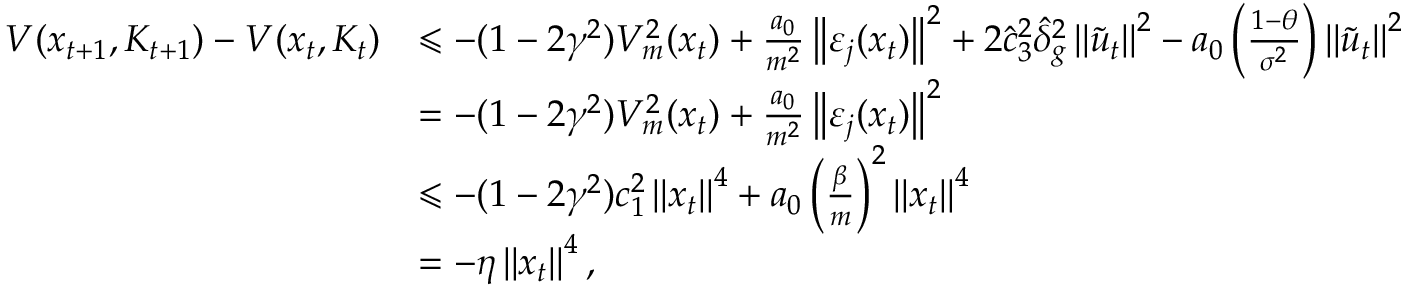Convert formula to latex. <formula><loc_0><loc_0><loc_500><loc_500>\begin{array} { r l } { V ( x _ { t + 1 } , K _ { t + 1 } ) - V ( x _ { t } , K _ { t } ) } & { \leqslant - ( 1 - 2 \gamma ^ { 2 } ) V _ { m } ^ { 2 } ( x _ { t } ) + \frac { a _ { 0 } } { m ^ { 2 } } \left \| \varepsilon _ { j } ( x _ { t } ) \right \| ^ { 2 } + 2 \hat { c } _ { 3 } ^ { 2 } \hat { \delta } _ { g } ^ { 2 } \left \| \tilde { u } _ { t } \right \| ^ { 2 } - a _ { 0 } \left ( \frac { 1 - \theta } { \sigma ^ { 2 } } \right ) \left \| \tilde { u } _ { t } \right \| ^ { 2 } } \\ & { = - ( 1 - 2 \gamma ^ { 2 } ) V _ { m } ^ { 2 } ( x _ { t } ) + \frac { a _ { 0 } } { m ^ { 2 } } \left \| \varepsilon _ { j } ( x _ { t } ) \right \| ^ { 2 } } \\ & { \leqslant - ( 1 - 2 \gamma ^ { 2 } ) c _ { 1 } ^ { 2 } \left \| x _ { t } \right \| ^ { 4 } + a _ { 0 } \left ( \frac { \beta } { m } \right ) ^ { 2 } \left \| x _ { t } \right \| ^ { 4 } } \\ & { = - \eta \left \| x _ { t } \right \| ^ { 4 } , } \end{array}</formula> 